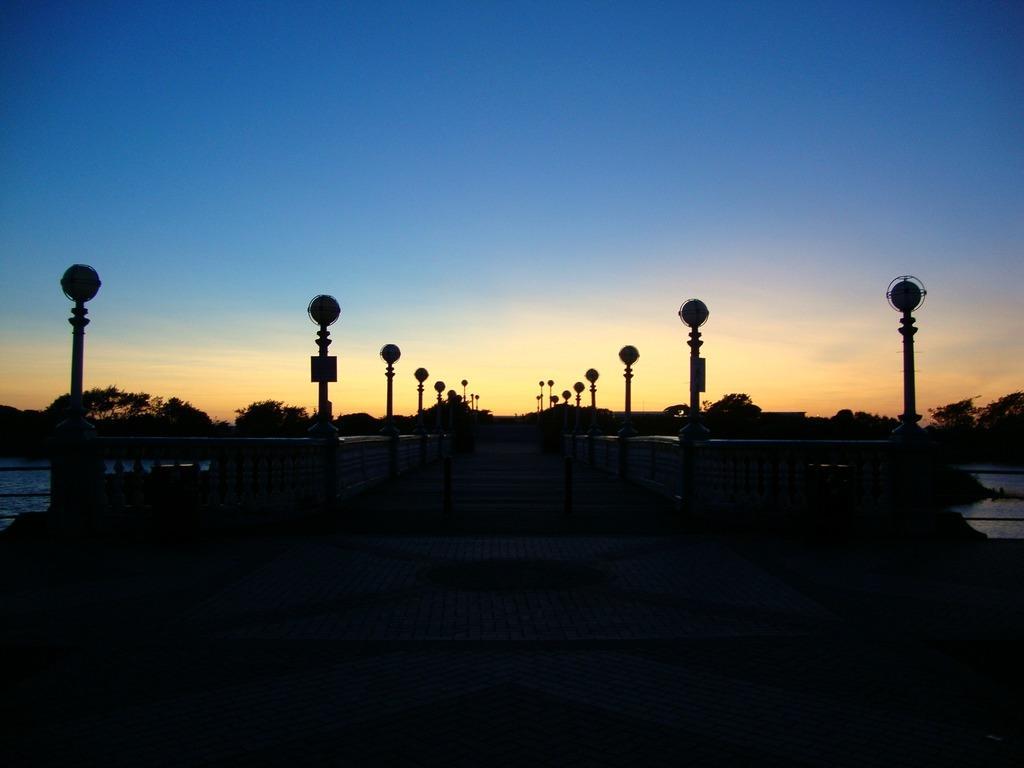In one or two sentences, can you explain what this image depicts? At the bottom the image is dark. In the background there are poles,trees,water and clouds in the sky. 